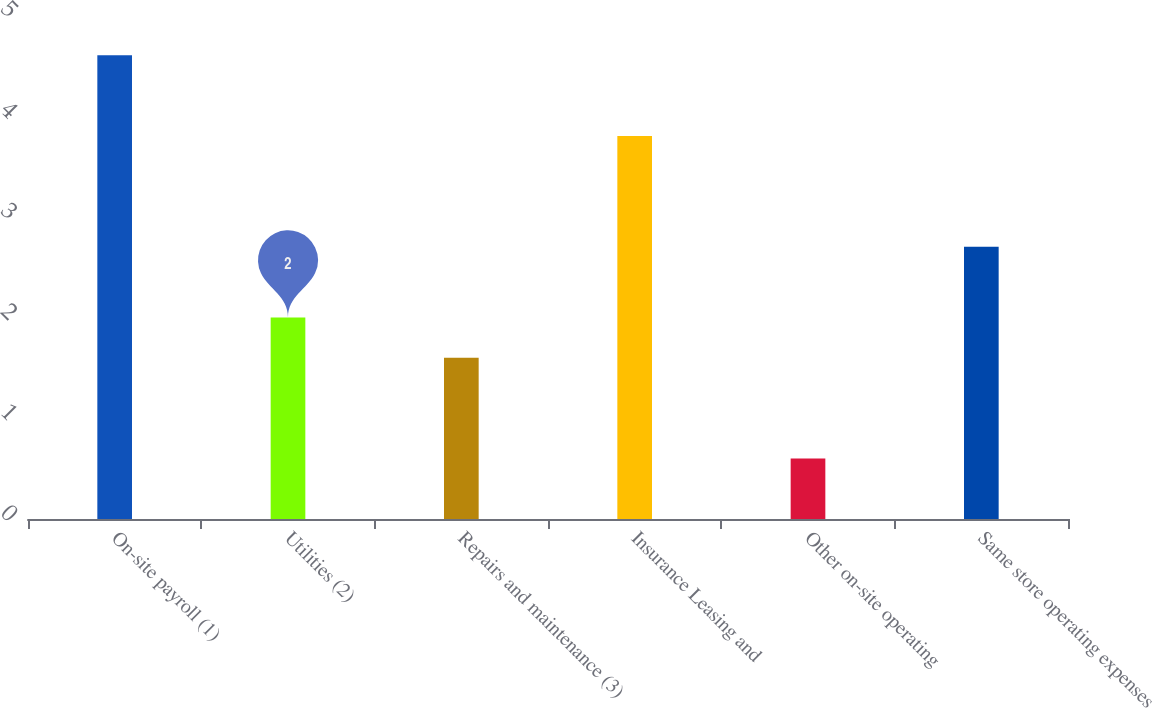<chart> <loc_0><loc_0><loc_500><loc_500><bar_chart><fcel>On-site payroll (1)<fcel>Utilities (2)<fcel>Repairs and maintenance (3)<fcel>Insurance Leasing and<fcel>Other on-site operating<fcel>Same store operating expenses<nl><fcel>4.6<fcel>2<fcel>1.6<fcel>3.8<fcel>0.6<fcel>2.7<nl></chart> 